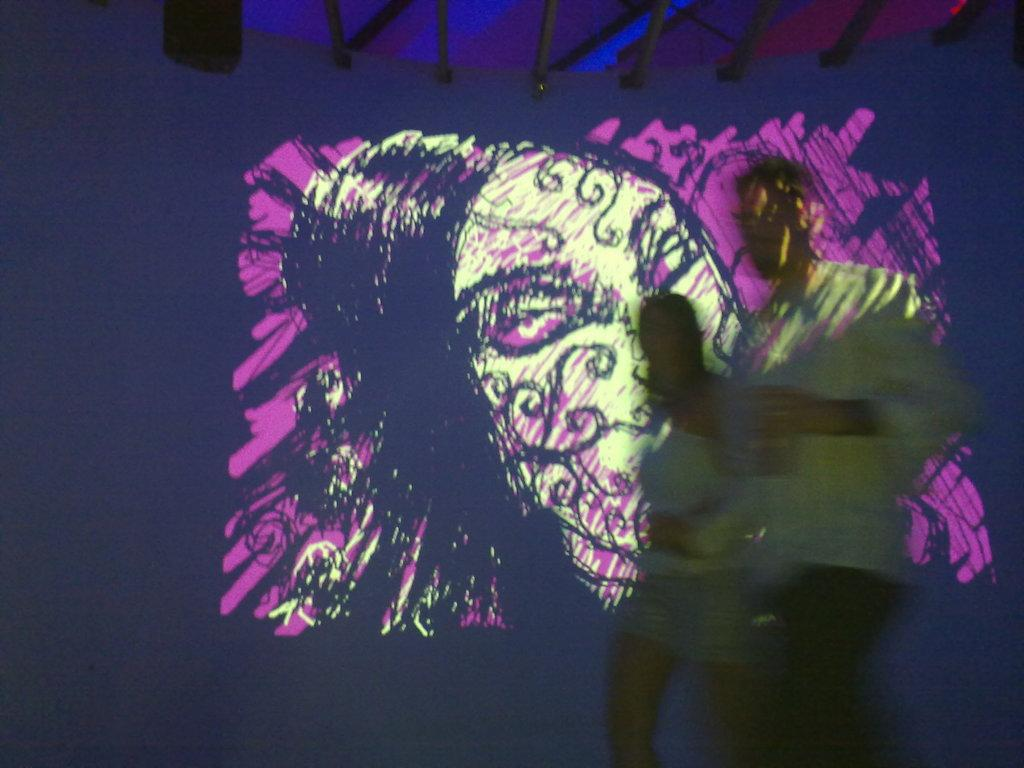What is the main subject of the image? The main subject of the image is a painting on a screen. What does the painting depict? The painting depicts a shadow of two people. How many boats are visible in the image? There are no boats present in the image. What type of stranger can be seen in the image? There is no stranger present in the image; the painting depicts a shadow of two people. 